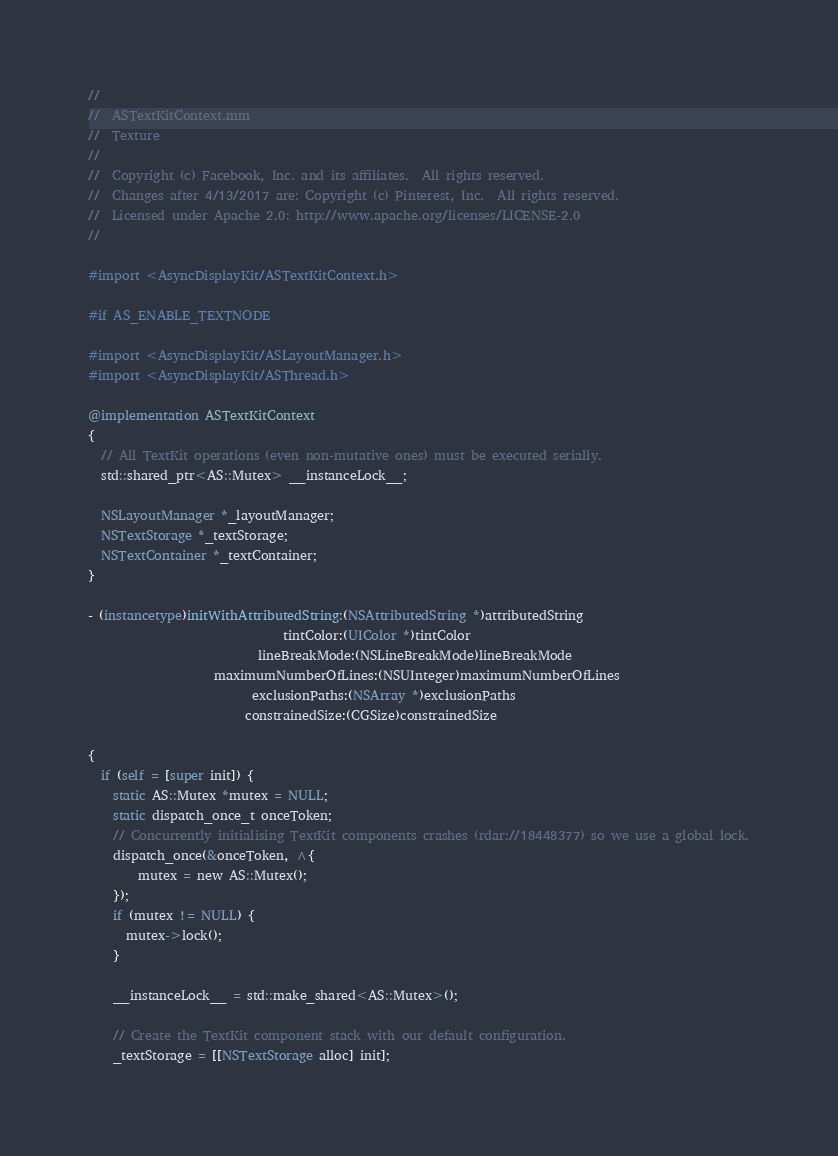Convert code to text. <code><loc_0><loc_0><loc_500><loc_500><_ObjectiveC_>//
//  ASTextKitContext.mm
//  Texture
//
//  Copyright (c) Facebook, Inc. and its affiliates.  All rights reserved.
//  Changes after 4/13/2017 are: Copyright (c) Pinterest, Inc.  All rights reserved.
//  Licensed under Apache 2.0: http://www.apache.org/licenses/LICENSE-2.0
//

#import <AsyncDisplayKit/ASTextKitContext.h>

#if AS_ENABLE_TEXTNODE

#import <AsyncDisplayKit/ASLayoutManager.h>
#import <AsyncDisplayKit/ASThread.h>

@implementation ASTextKitContext
{
  // All TextKit operations (even non-mutative ones) must be executed serially.
  std::shared_ptr<AS::Mutex> __instanceLock__;

  NSLayoutManager *_layoutManager;
  NSTextStorage *_textStorage;
  NSTextContainer *_textContainer;
}

- (instancetype)initWithAttributedString:(NSAttributedString *)attributedString
                               tintColor:(UIColor *)tintColor
                           lineBreakMode:(NSLineBreakMode)lineBreakMode
                    maximumNumberOfLines:(NSUInteger)maximumNumberOfLines
                          exclusionPaths:(NSArray *)exclusionPaths
                         constrainedSize:(CGSize)constrainedSize

{
  if (self = [super init]) {
    static AS::Mutex *mutex = NULL;
    static dispatch_once_t onceToken;
    // Concurrently initialising TextKit components crashes (rdar://18448377) so we use a global lock.
    dispatch_once(&onceToken, ^{
        mutex = new AS::Mutex();
    });
    if (mutex != NULL) {
      mutex->lock();
    }
    
    __instanceLock__ = std::make_shared<AS::Mutex>();
    
    // Create the TextKit component stack with our default configuration.
    _textStorage = [[NSTextStorage alloc] init];</code> 